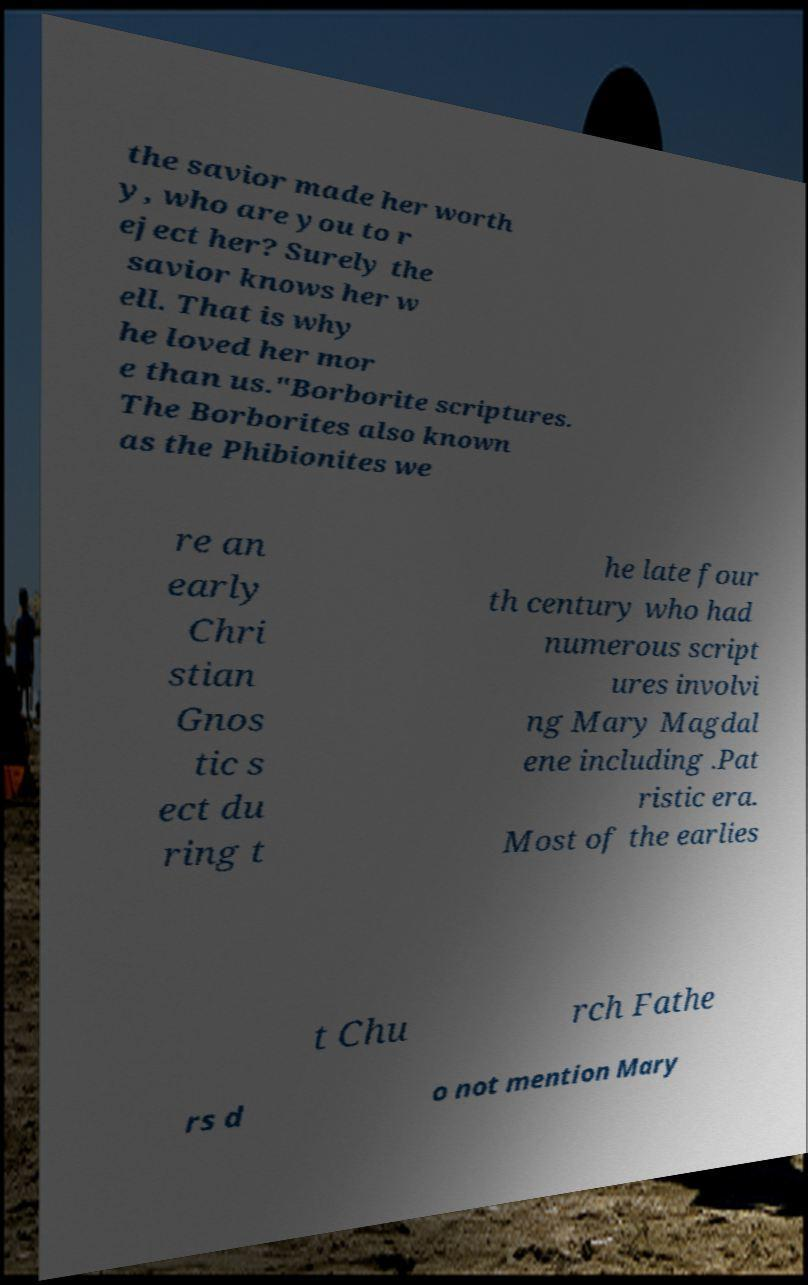Please read and relay the text visible in this image. What does it say? the savior made her worth y, who are you to r eject her? Surely the savior knows her w ell. That is why he loved her mor e than us."Borborite scriptures. The Borborites also known as the Phibionites we re an early Chri stian Gnos tic s ect du ring t he late four th century who had numerous script ures involvi ng Mary Magdal ene including .Pat ristic era. Most of the earlies t Chu rch Fathe rs d o not mention Mary 